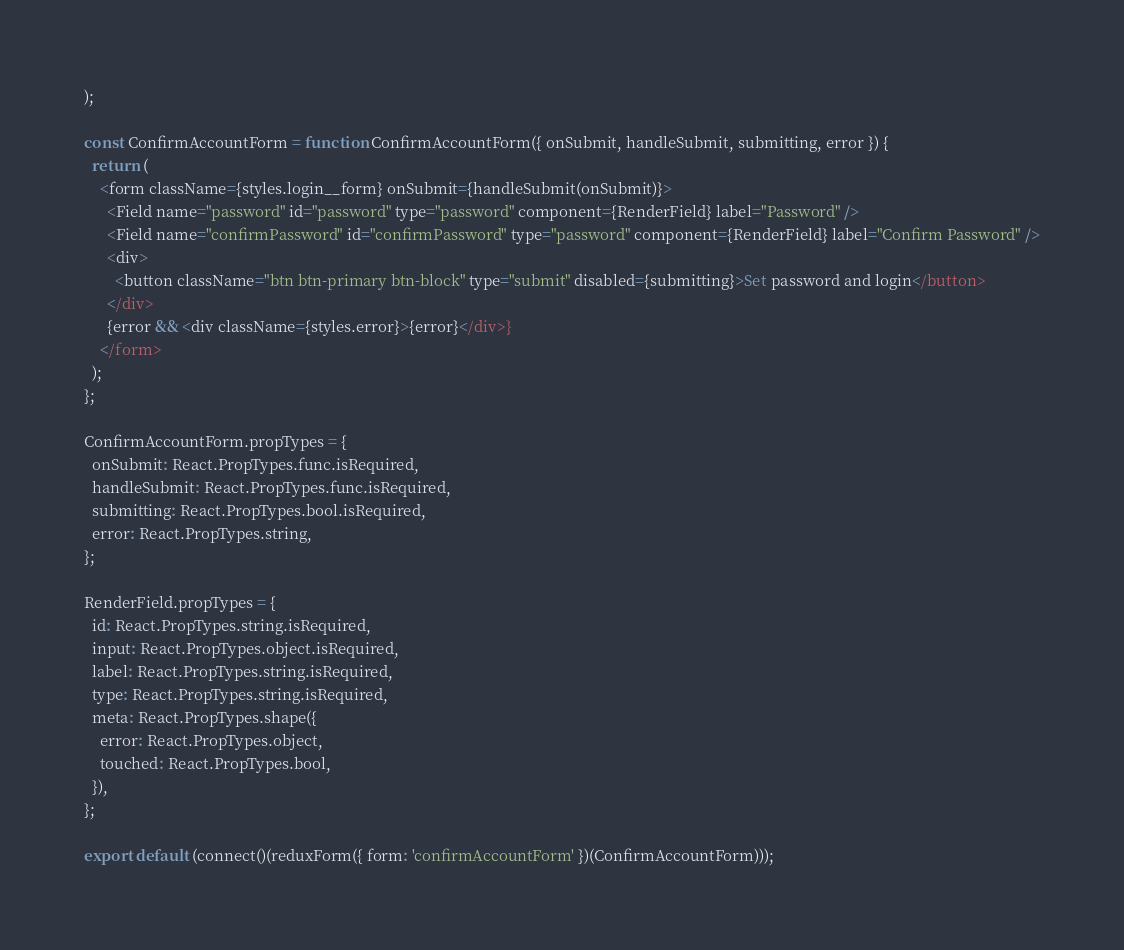Convert code to text. <code><loc_0><loc_0><loc_500><loc_500><_JavaScript_>);

const ConfirmAccountForm = function ConfirmAccountForm({ onSubmit, handleSubmit, submitting, error }) {
  return (
    <form className={styles.login__form} onSubmit={handleSubmit(onSubmit)}>
      <Field name="password" id="password" type="password" component={RenderField} label="Password" />
      <Field name="confirmPassword" id="confirmPassword" type="password" component={RenderField} label="Confirm Password" />
      <div>
        <button className="btn btn-primary btn-block" type="submit" disabled={submitting}>Set password and login</button>
      </div>
      {error && <div className={styles.error}>{error}</div>}
    </form>
  );
};

ConfirmAccountForm.propTypes = {
  onSubmit: React.PropTypes.func.isRequired,
  handleSubmit: React.PropTypes.func.isRequired,
  submitting: React.PropTypes.bool.isRequired,
  error: React.PropTypes.string,
};

RenderField.propTypes = {
  id: React.PropTypes.string.isRequired,
  input: React.PropTypes.object.isRequired,
  label: React.PropTypes.string.isRequired,
  type: React.PropTypes.string.isRequired,
  meta: React.PropTypes.shape({
    error: React.PropTypes.object,
    touched: React.PropTypes.bool,
  }),
};

export default (connect()(reduxForm({ form: 'confirmAccountForm' })(ConfirmAccountForm)));
</code> 